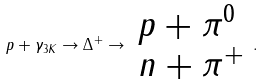<formula> <loc_0><loc_0><loc_500><loc_500>p + \gamma _ { 3 K } \rightarrow \Delta ^ { + } \rightarrow \begin{array} { l } p + \pi ^ { 0 } \\ n + \pi ^ { + } \end{array} .</formula> 